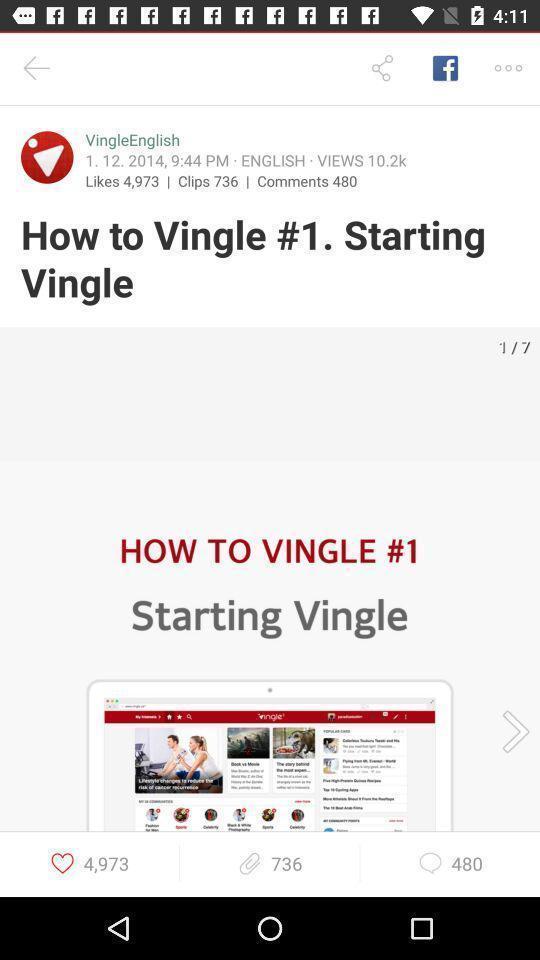Describe the key features of this screenshot. Steps for a social networking website. 